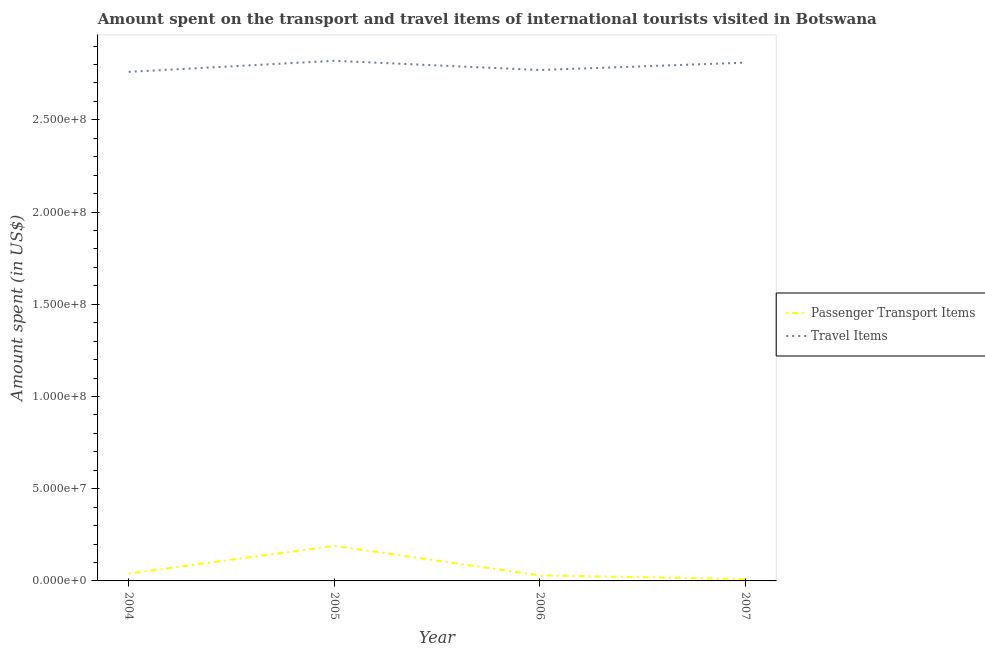How many different coloured lines are there?
Keep it short and to the point. 2. What is the amount spent in travel items in 2007?
Provide a short and direct response. 2.81e+08. Across all years, what is the maximum amount spent in travel items?
Ensure brevity in your answer.  2.82e+08. Across all years, what is the minimum amount spent on passenger transport items?
Provide a succinct answer. 1.00e+06. What is the total amount spent in travel items in the graph?
Make the answer very short. 1.12e+09. What is the difference between the amount spent on passenger transport items in 2004 and that in 2005?
Your answer should be compact. -1.50e+07. What is the difference between the amount spent in travel items in 2004 and the amount spent on passenger transport items in 2005?
Provide a short and direct response. 2.57e+08. What is the average amount spent on passenger transport items per year?
Your answer should be very brief. 6.75e+06. In the year 2005, what is the difference between the amount spent in travel items and amount spent on passenger transport items?
Provide a short and direct response. 2.63e+08. What is the ratio of the amount spent in travel items in 2004 to that in 2006?
Your answer should be compact. 1. Is the difference between the amount spent in travel items in 2004 and 2005 greater than the difference between the amount spent on passenger transport items in 2004 and 2005?
Keep it short and to the point. Yes. What is the difference between the highest and the second highest amount spent on passenger transport items?
Offer a very short reply. 1.50e+07. What is the difference between the highest and the lowest amount spent in travel items?
Keep it short and to the point. 6.00e+06. In how many years, is the amount spent on passenger transport items greater than the average amount spent on passenger transport items taken over all years?
Your answer should be compact. 1. Is the sum of the amount spent in travel items in 2006 and 2007 greater than the maximum amount spent on passenger transport items across all years?
Provide a succinct answer. Yes. Is the amount spent on passenger transport items strictly less than the amount spent in travel items over the years?
Make the answer very short. Yes. How many lines are there?
Give a very brief answer. 2. What is the difference between two consecutive major ticks on the Y-axis?
Offer a very short reply. 5.00e+07. Does the graph contain grids?
Provide a succinct answer. No. Where does the legend appear in the graph?
Your response must be concise. Center right. How many legend labels are there?
Offer a terse response. 2. How are the legend labels stacked?
Give a very brief answer. Vertical. What is the title of the graph?
Make the answer very short. Amount spent on the transport and travel items of international tourists visited in Botswana. Does "Age 65(female)" appear as one of the legend labels in the graph?
Keep it short and to the point. No. What is the label or title of the X-axis?
Provide a short and direct response. Year. What is the label or title of the Y-axis?
Make the answer very short. Amount spent (in US$). What is the Amount spent (in US$) of Passenger Transport Items in 2004?
Give a very brief answer. 4.00e+06. What is the Amount spent (in US$) of Travel Items in 2004?
Keep it short and to the point. 2.76e+08. What is the Amount spent (in US$) of Passenger Transport Items in 2005?
Your answer should be compact. 1.90e+07. What is the Amount spent (in US$) in Travel Items in 2005?
Keep it short and to the point. 2.82e+08. What is the Amount spent (in US$) of Travel Items in 2006?
Make the answer very short. 2.77e+08. What is the Amount spent (in US$) in Passenger Transport Items in 2007?
Offer a very short reply. 1.00e+06. What is the Amount spent (in US$) of Travel Items in 2007?
Make the answer very short. 2.81e+08. Across all years, what is the maximum Amount spent (in US$) of Passenger Transport Items?
Your response must be concise. 1.90e+07. Across all years, what is the maximum Amount spent (in US$) in Travel Items?
Your answer should be very brief. 2.82e+08. Across all years, what is the minimum Amount spent (in US$) in Travel Items?
Provide a succinct answer. 2.76e+08. What is the total Amount spent (in US$) in Passenger Transport Items in the graph?
Offer a terse response. 2.70e+07. What is the total Amount spent (in US$) of Travel Items in the graph?
Ensure brevity in your answer.  1.12e+09. What is the difference between the Amount spent (in US$) in Passenger Transport Items in 2004 and that in 2005?
Provide a short and direct response. -1.50e+07. What is the difference between the Amount spent (in US$) in Travel Items in 2004 and that in 2005?
Provide a succinct answer. -6.00e+06. What is the difference between the Amount spent (in US$) of Passenger Transport Items in 2004 and that in 2006?
Your response must be concise. 1.00e+06. What is the difference between the Amount spent (in US$) of Travel Items in 2004 and that in 2006?
Your response must be concise. -1.00e+06. What is the difference between the Amount spent (in US$) in Travel Items in 2004 and that in 2007?
Your answer should be compact. -5.00e+06. What is the difference between the Amount spent (in US$) of Passenger Transport Items in 2005 and that in 2006?
Give a very brief answer. 1.60e+07. What is the difference between the Amount spent (in US$) of Travel Items in 2005 and that in 2006?
Your answer should be very brief. 5.00e+06. What is the difference between the Amount spent (in US$) of Passenger Transport Items in 2005 and that in 2007?
Give a very brief answer. 1.80e+07. What is the difference between the Amount spent (in US$) of Travel Items in 2005 and that in 2007?
Provide a succinct answer. 1.00e+06. What is the difference between the Amount spent (in US$) of Passenger Transport Items in 2006 and that in 2007?
Ensure brevity in your answer.  2.00e+06. What is the difference between the Amount spent (in US$) in Passenger Transport Items in 2004 and the Amount spent (in US$) in Travel Items in 2005?
Provide a short and direct response. -2.78e+08. What is the difference between the Amount spent (in US$) in Passenger Transport Items in 2004 and the Amount spent (in US$) in Travel Items in 2006?
Offer a terse response. -2.73e+08. What is the difference between the Amount spent (in US$) in Passenger Transport Items in 2004 and the Amount spent (in US$) in Travel Items in 2007?
Keep it short and to the point. -2.77e+08. What is the difference between the Amount spent (in US$) in Passenger Transport Items in 2005 and the Amount spent (in US$) in Travel Items in 2006?
Give a very brief answer. -2.58e+08. What is the difference between the Amount spent (in US$) in Passenger Transport Items in 2005 and the Amount spent (in US$) in Travel Items in 2007?
Give a very brief answer. -2.62e+08. What is the difference between the Amount spent (in US$) of Passenger Transport Items in 2006 and the Amount spent (in US$) of Travel Items in 2007?
Keep it short and to the point. -2.78e+08. What is the average Amount spent (in US$) of Passenger Transport Items per year?
Your answer should be very brief. 6.75e+06. What is the average Amount spent (in US$) of Travel Items per year?
Your answer should be very brief. 2.79e+08. In the year 2004, what is the difference between the Amount spent (in US$) in Passenger Transport Items and Amount spent (in US$) in Travel Items?
Provide a short and direct response. -2.72e+08. In the year 2005, what is the difference between the Amount spent (in US$) in Passenger Transport Items and Amount spent (in US$) in Travel Items?
Offer a terse response. -2.63e+08. In the year 2006, what is the difference between the Amount spent (in US$) of Passenger Transport Items and Amount spent (in US$) of Travel Items?
Offer a terse response. -2.74e+08. In the year 2007, what is the difference between the Amount spent (in US$) of Passenger Transport Items and Amount spent (in US$) of Travel Items?
Offer a terse response. -2.80e+08. What is the ratio of the Amount spent (in US$) in Passenger Transport Items in 2004 to that in 2005?
Make the answer very short. 0.21. What is the ratio of the Amount spent (in US$) of Travel Items in 2004 to that in 2005?
Your response must be concise. 0.98. What is the ratio of the Amount spent (in US$) in Passenger Transport Items in 2004 to that in 2006?
Your answer should be very brief. 1.33. What is the ratio of the Amount spent (in US$) in Travel Items in 2004 to that in 2006?
Make the answer very short. 1. What is the ratio of the Amount spent (in US$) of Passenger Transport Items in 2004 to that in 2007?
Offer a terse response. 4. What is the ratio of the Amount spent (in US$) in Travel Items in 2004 to that in 2007?
Offer a terse response. 0.98. What is the ratio of the Amount spent (in US$) in Passenger Transport Items in 2005 to that in 2006?
Offer a terse response. 6.33. What is the ratio of the Amount spent (in US$) of Travel Items in 2005 to that in 2006?
Ensure brevity in your answer.  1.02. What is the ratio of the Amount spent (in US$) in Passenger Transport Items in 2005 to that in 2007?
Your response must be concise. 19. What is the ratio of the Amount spent (in US$) of Travel Items in 2005 to that in 2007?
Offer a very short reply. 1. What is the ratio of the Amount spent (in US$) in Travel Items in 2006 to that in 2007?
Make the answer very short. 0.99. What is the difference between the highest and the second highest Amount spent (in US$) in Passenger Transport Items?
Provide a succinct answer. 1.50e+07. What is the difference between the highest and the second highest Amount spent (in US$) of Travel Items?
Offer a terse response. 1.00e+06. What is the difference between the highest and the lowest Amount spent (in US$) of Passenger Transport Items?
Keep it short and to the point. 1.80e+07. What is the difference between the highest and the lowest Amount spent (in US$) of Travel Items?
Your answer should be very brief. 6.00e+06. 